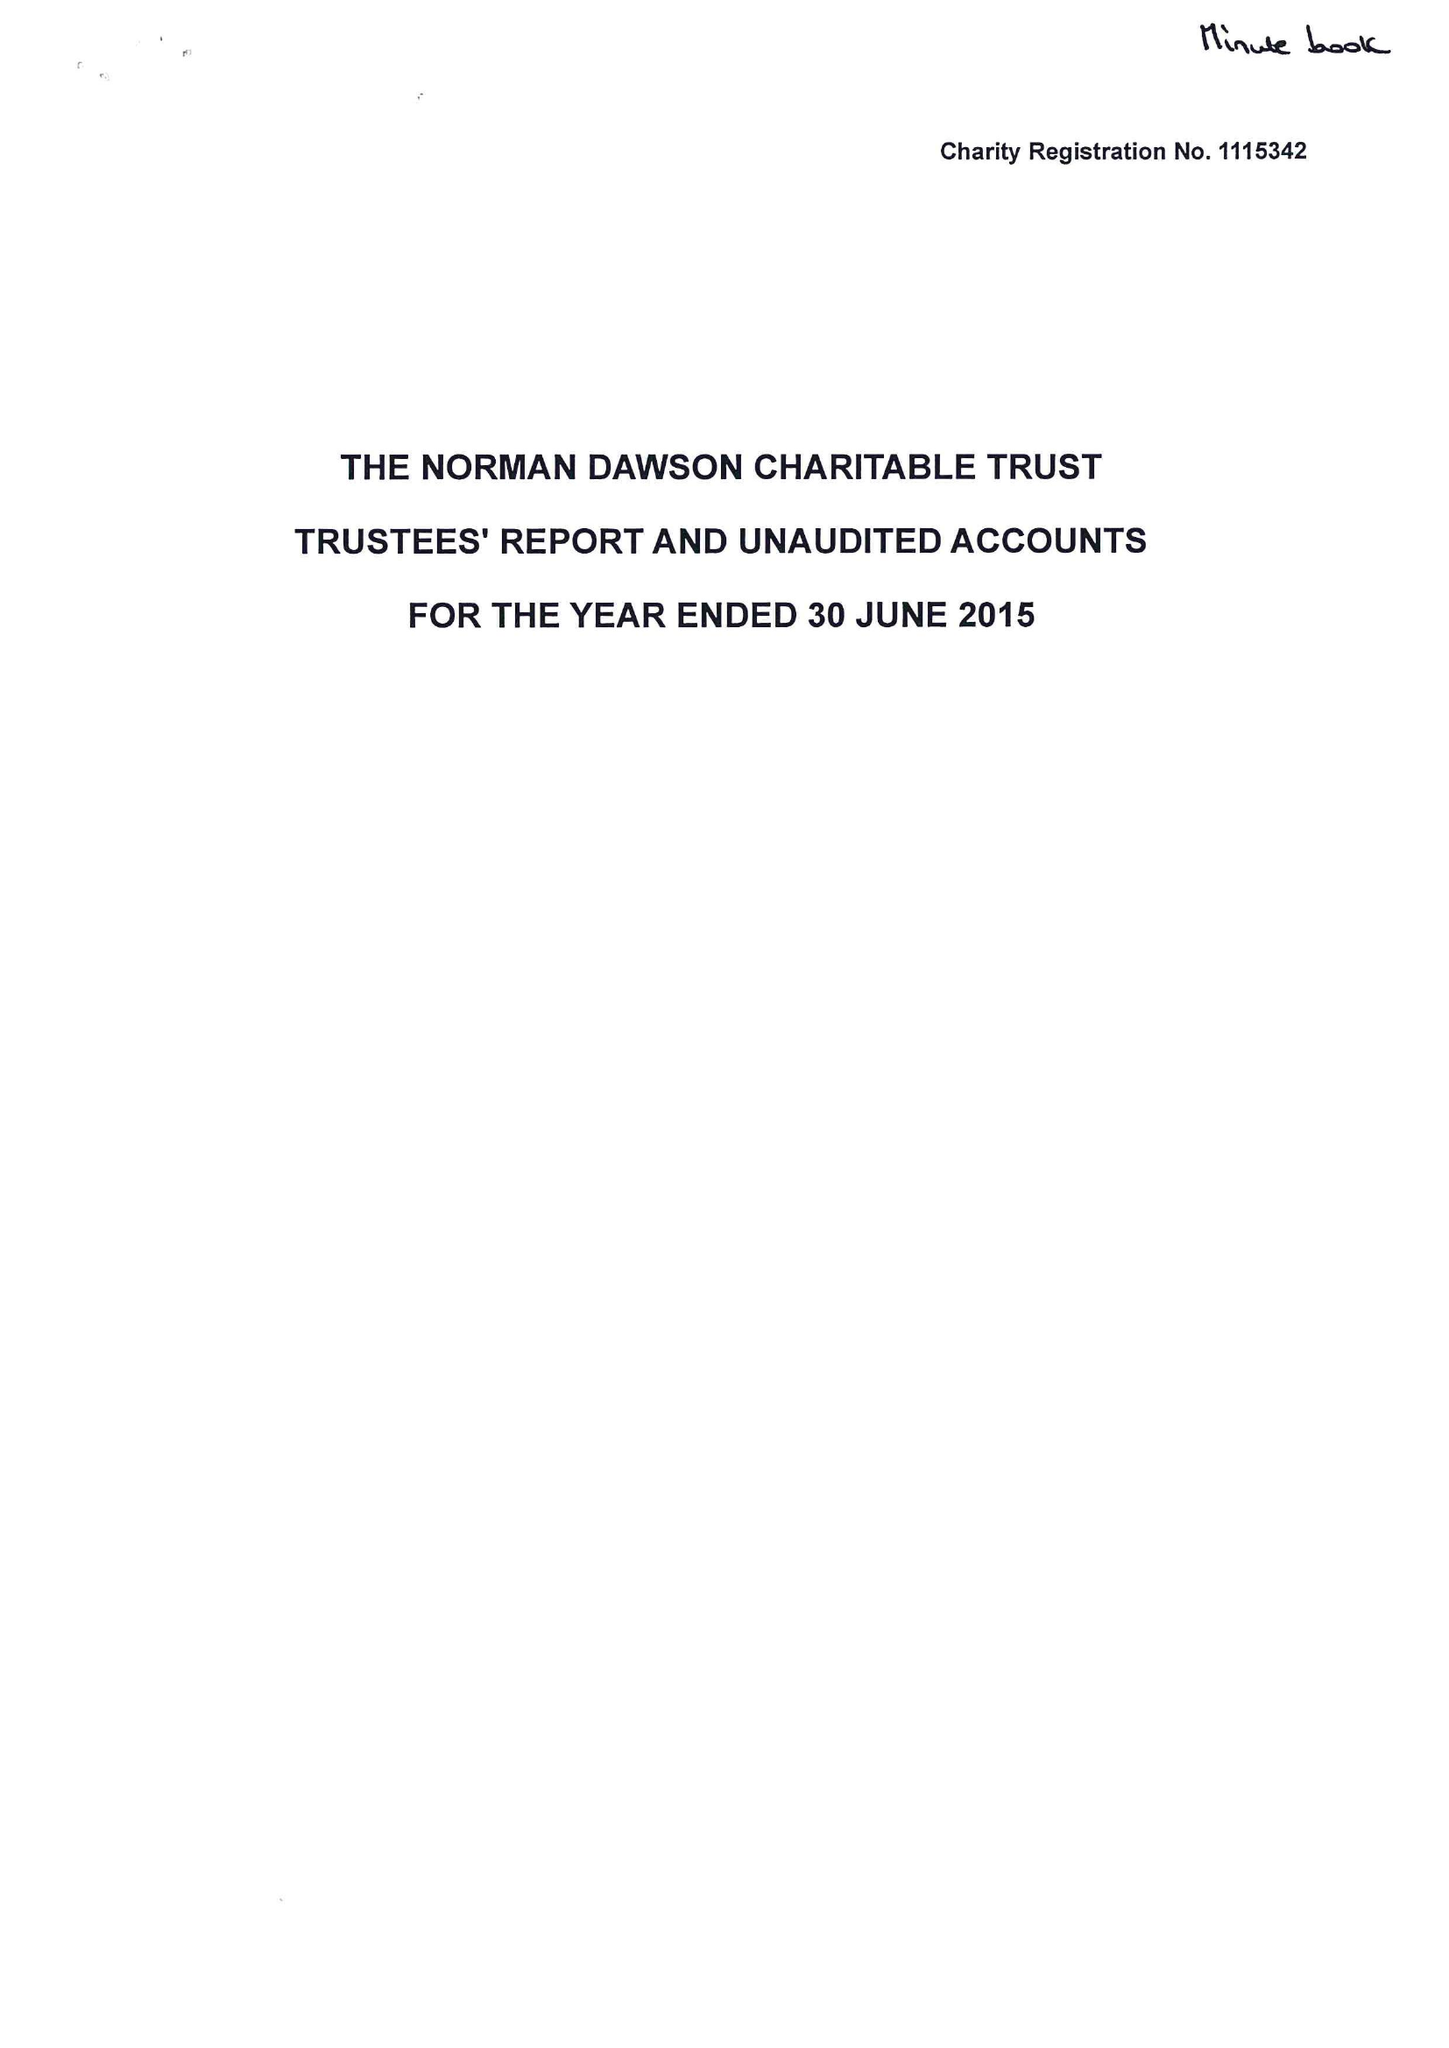What is the value for the charity_number?
Answer the question using a single word or phrase. 1115342 